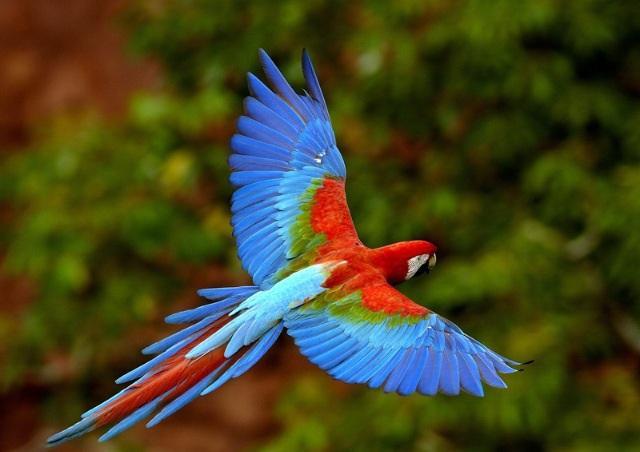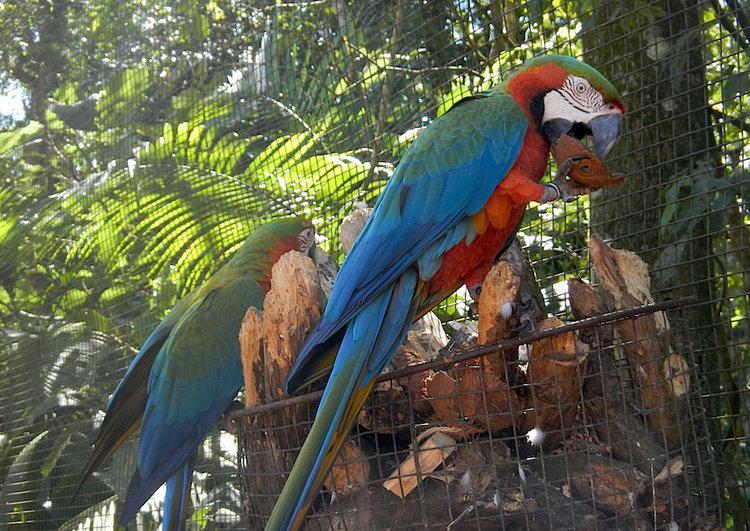The first image is the image on the left, the second image is the image on the right. Examine the images to the left and right. Is the description "At least one image contains a macaw in flight." accurate? Answer yes or no. Yes. 